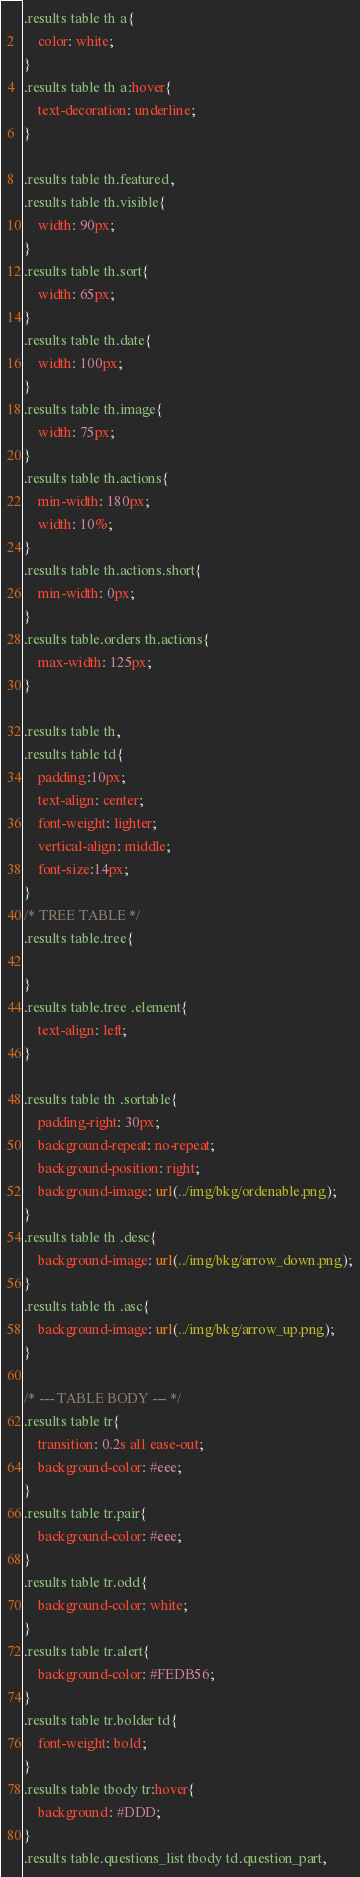<code> <loc_0><loc_0><loc_500><loc_500><_CSS_>.results table th a{
    color: white;
}
.results table th a:hover{
    text-decoration: underline;
}

.results table th.featured,
.results table th.visible{
    width: 90px;
}
.results table th.sort{
    width: 65px;
}
.results table th.date{
    width: 100px;
}
.results table th.image{
    width: 75px;
}
.results table th.actions{
    min-width: 180px;
    width: 10%;
}
.results table th.actions.short{
    min-width: 0px;
}
.results table.orders th.actions{
    max-width: 125px;
}

.results table th,
.results table td{
    padding:10px;
    text-align: center;
    font-weight: lighter;
    vertical-align: middle;
    font-size:14px;
}
/* TREE TABLE */
.results table.tree{

}
.results table.tree .element{
    text-align: left;
}

.results table th .sortable{
    padding-right: 30px;
    background-repeat: no-repeat;
    background-position: right;
    background-image: url(../img/bkg/ordenable.png);
}
.results table th .desc{
    background-image: url(../img/bkg/arrow_down.png);
}
.results table th .asc{
    background-image: url(../img/bkg/arrow_up.png);
}

/* --- TABLE BODY --- */
.results table tr{
    transition: 0.2s all ease-out;
    background-color: #eee;
}
.results table tr.pair{
    background-color: #eee;
}
.results table tr.odd{
    background-color: white;
}
.results table tr.alert{
    background-color: #FEDB56;
}
.results table tr.bolder td{
    font-weight: bold;
}
.results table tbody tr:hover{
    background: #DDD;
}
.results table.questions_list tbody td.question_part,</code> 